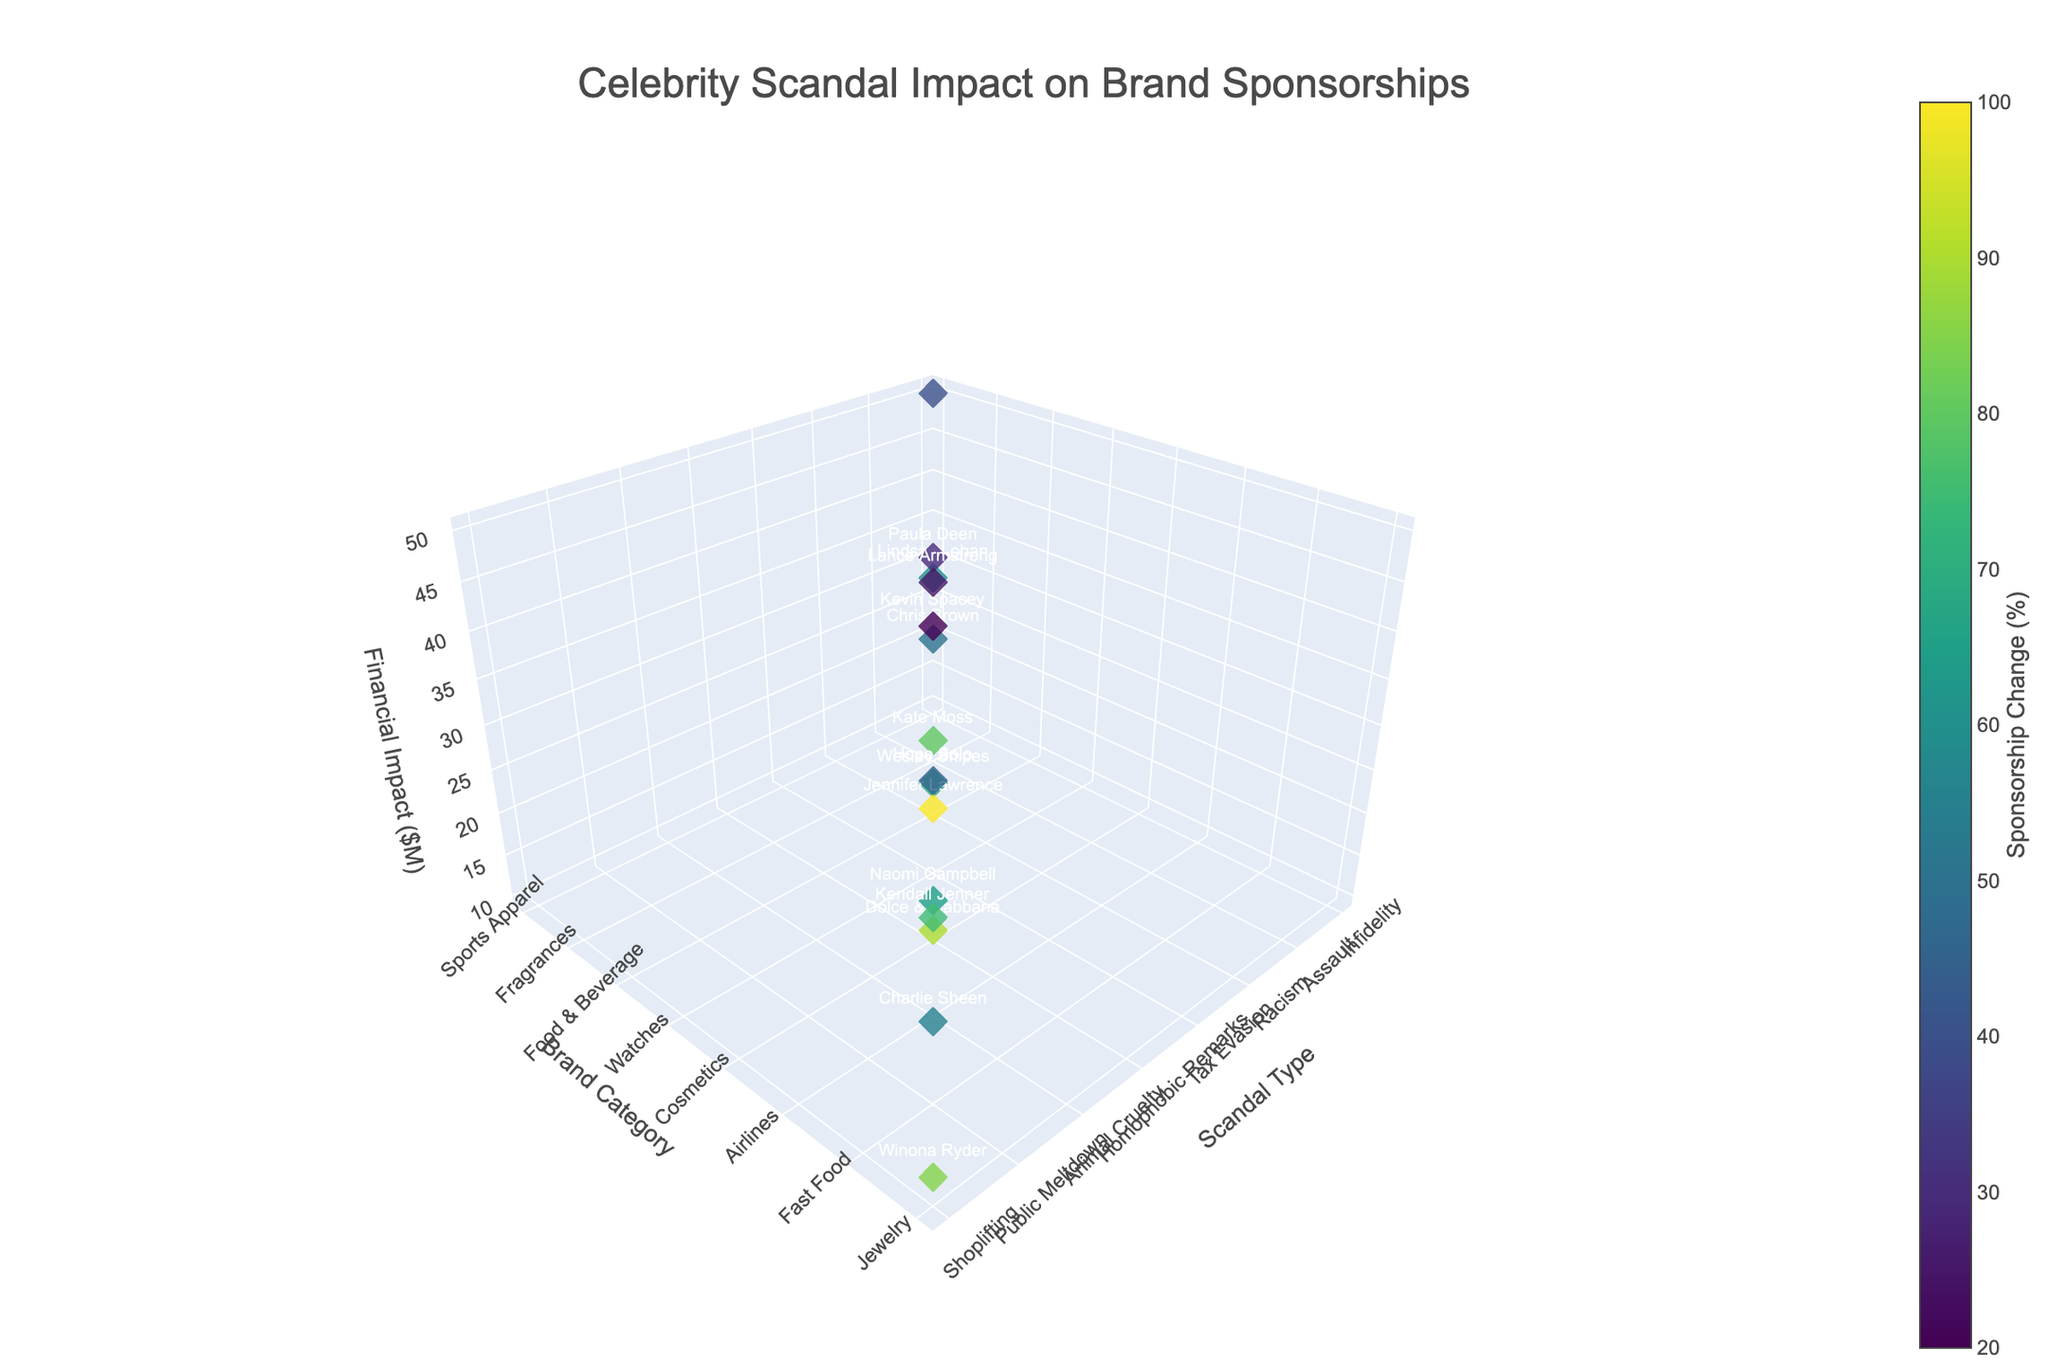what's the title of the plot? The title of the plot is visible at the top and indicates the theme of the visualization. It reads "Celebrity Scandal Impact on Brand Sponsorships".
Answer: Celebrity Scandal Impact on Brand Sponsorships what are the three axes labeled? The three axes are labeled to indicate the dimensions being analyzed. The x-axis is labeled 'Scandal Type', the y-axis is labeled 'Brand Category', and the z-axis is labeled 'Financial Impact ($M)'.
Answer: Scandal Type, Brand Category, Financial Impact ($M) which celebrity had the highest sponsorship decrease? By observing the points and their associated text labels, we can identify the celebrity with the most negative Sponsorship Change (%). Kevin Spacey, involved in a Sexual Harassment scandal, had a -100% sponsorship change.
Answer: Kevin Spacey compare the financial impact between the DUI scandal and drug use scandal Checking the markers associated with these scandal types, DUI scandal (Lindsay Lohan) has a financial impact of $30 million, while the drug use scandal (Kate Moss) has a financial impact of $15 million. So, DUI has a higher financial impact.
Answer: DUI scandal has a higher financial impact what’s the average financial impact of scandals in the food & beverage brand category? The only scandal in the 'Food & Beverage' category is associated with Paula Deen, which has a financial impact of $40 million. Since there's only one data point, the average is simply $40 million.
Answer: $40 million which scandal type resulted in the smallest sponsorship change and what is its value? By examining the Sponsorship Change (%) values, the smallest change is observed for Jennifer Lawrence (leaked photos) which is -20%.
Answer: Leaked Photos, -20% what is the trend for financial impact and sponsorship change for celebrities involved in doping scandals? By locating Lance Armstrong's data point (associated with a doping scandal), we see that it has a financial impact of $45 million and a sponsorship change of -95%. Observing this relationship suggests high financial impact is associated with significant sponsorship changes.
Answer: High financial impact, significant sponsorship change how does financial impact differ between sports apparel and sportswear categories? Observing the "Sports Apparel" category (Tiger Woods, $50 million) and the "Sportswear" category (Hope Solo, $38 million), sports apparel's financial impact is higher than sportswear.
Answer: Sports Apparel is higher what is the relationship between financial impact and brand category in case of drug use? Focusing on the 'Drug Use' scandal (Kate Moss), we observe that it is associated with the 'Fashion' brand category and has a financial impact of $15 million.
Answer: Fashion, $15 million how many data points are there in the figure? There are sixteen rows in the data provided, indicating sixteen different data points visualized in the figure.
Answer: 16 